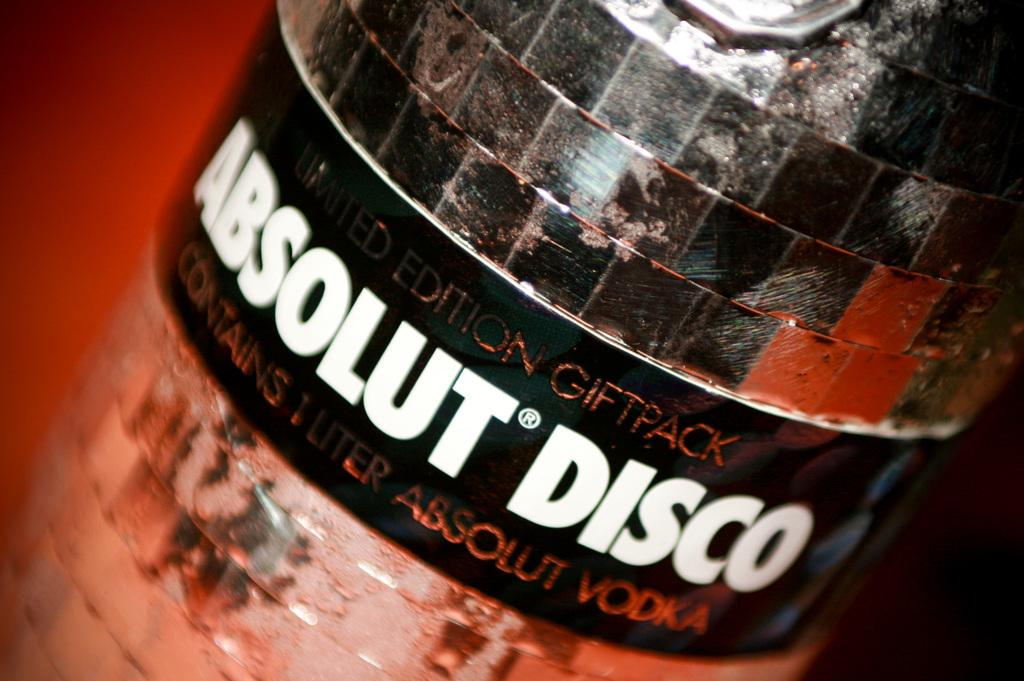<image>
Present a compact description of the photo's key features. A bottle of Absolut Disco Vodka came in a gift pack. 